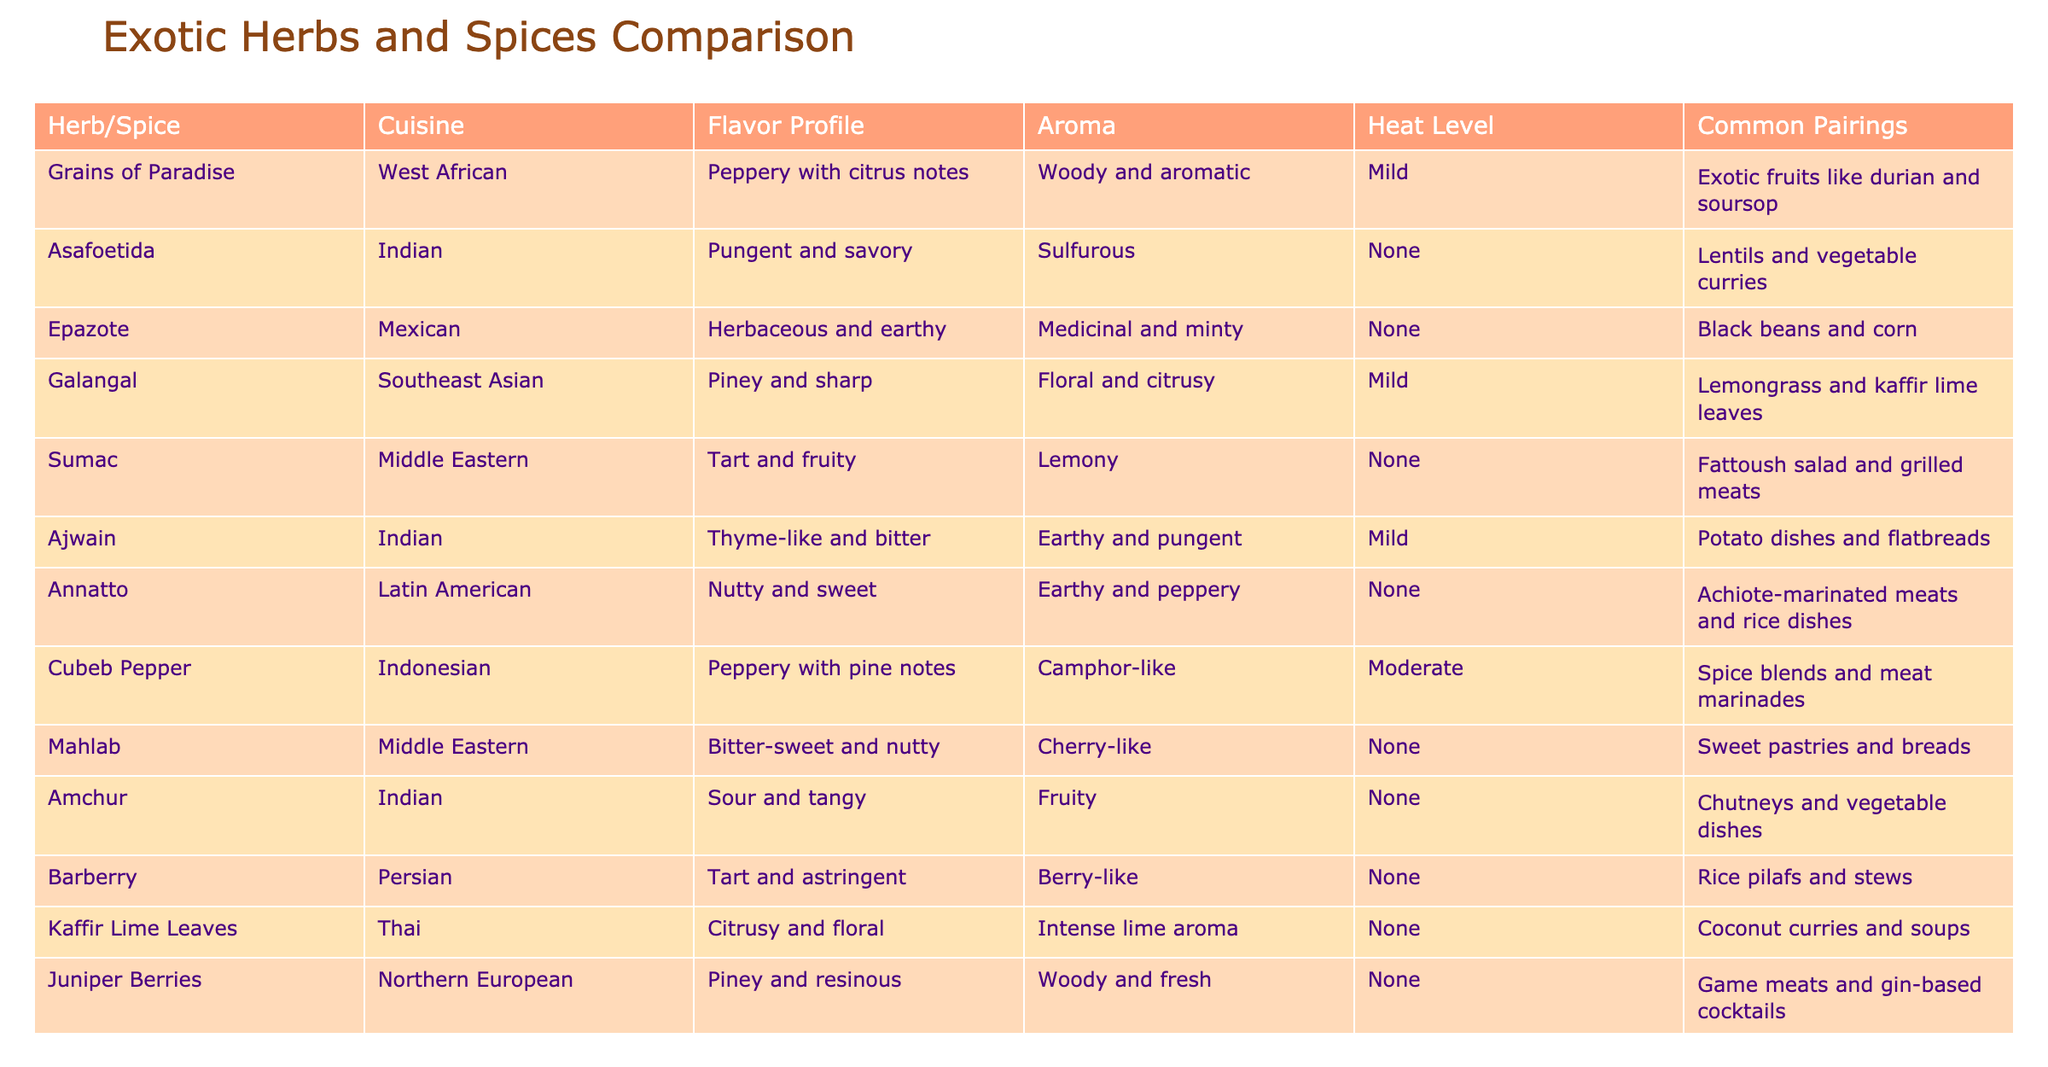What is the flavor profile of Epazote? According to the table, the flavor profile of Epazote is "Herbaceous and earthy."
Answer: Herbaceous and earthy Which herb or spice has the highest heat level? The only herb or spice that has a heat level listed as "Moderate" is Cubeb Pepper; all others are either "Mild" or "None."
Answer: Cubeb Pepper Are there any herbs or spices that pair well with black beans? The table indicates that Epazote is commonly paired with black beans, so this is true.
Answer: Yes What is the average heat level of the herbs and spices mentioned? There are the following heat levels: Mild (4), None (7), Moderate (1). The average is calculated by assigning values: Mild = 1, Moderate = 2, None = 0. Thus, the total heat value is (4*1 + 7*0 + 1*2) = 6, divided by 12 (the total number of herbs and spices), which gives 6/12 = 0.5, but since it's not possible to have half levels, we can summarize it as "Mild overall."
Answer: Mild overall Which cuisine features the nutty and sweet flavor of Annatto? The table states that the Annatto spice belongs to Latin American cuisine.
Answer: Latin American 